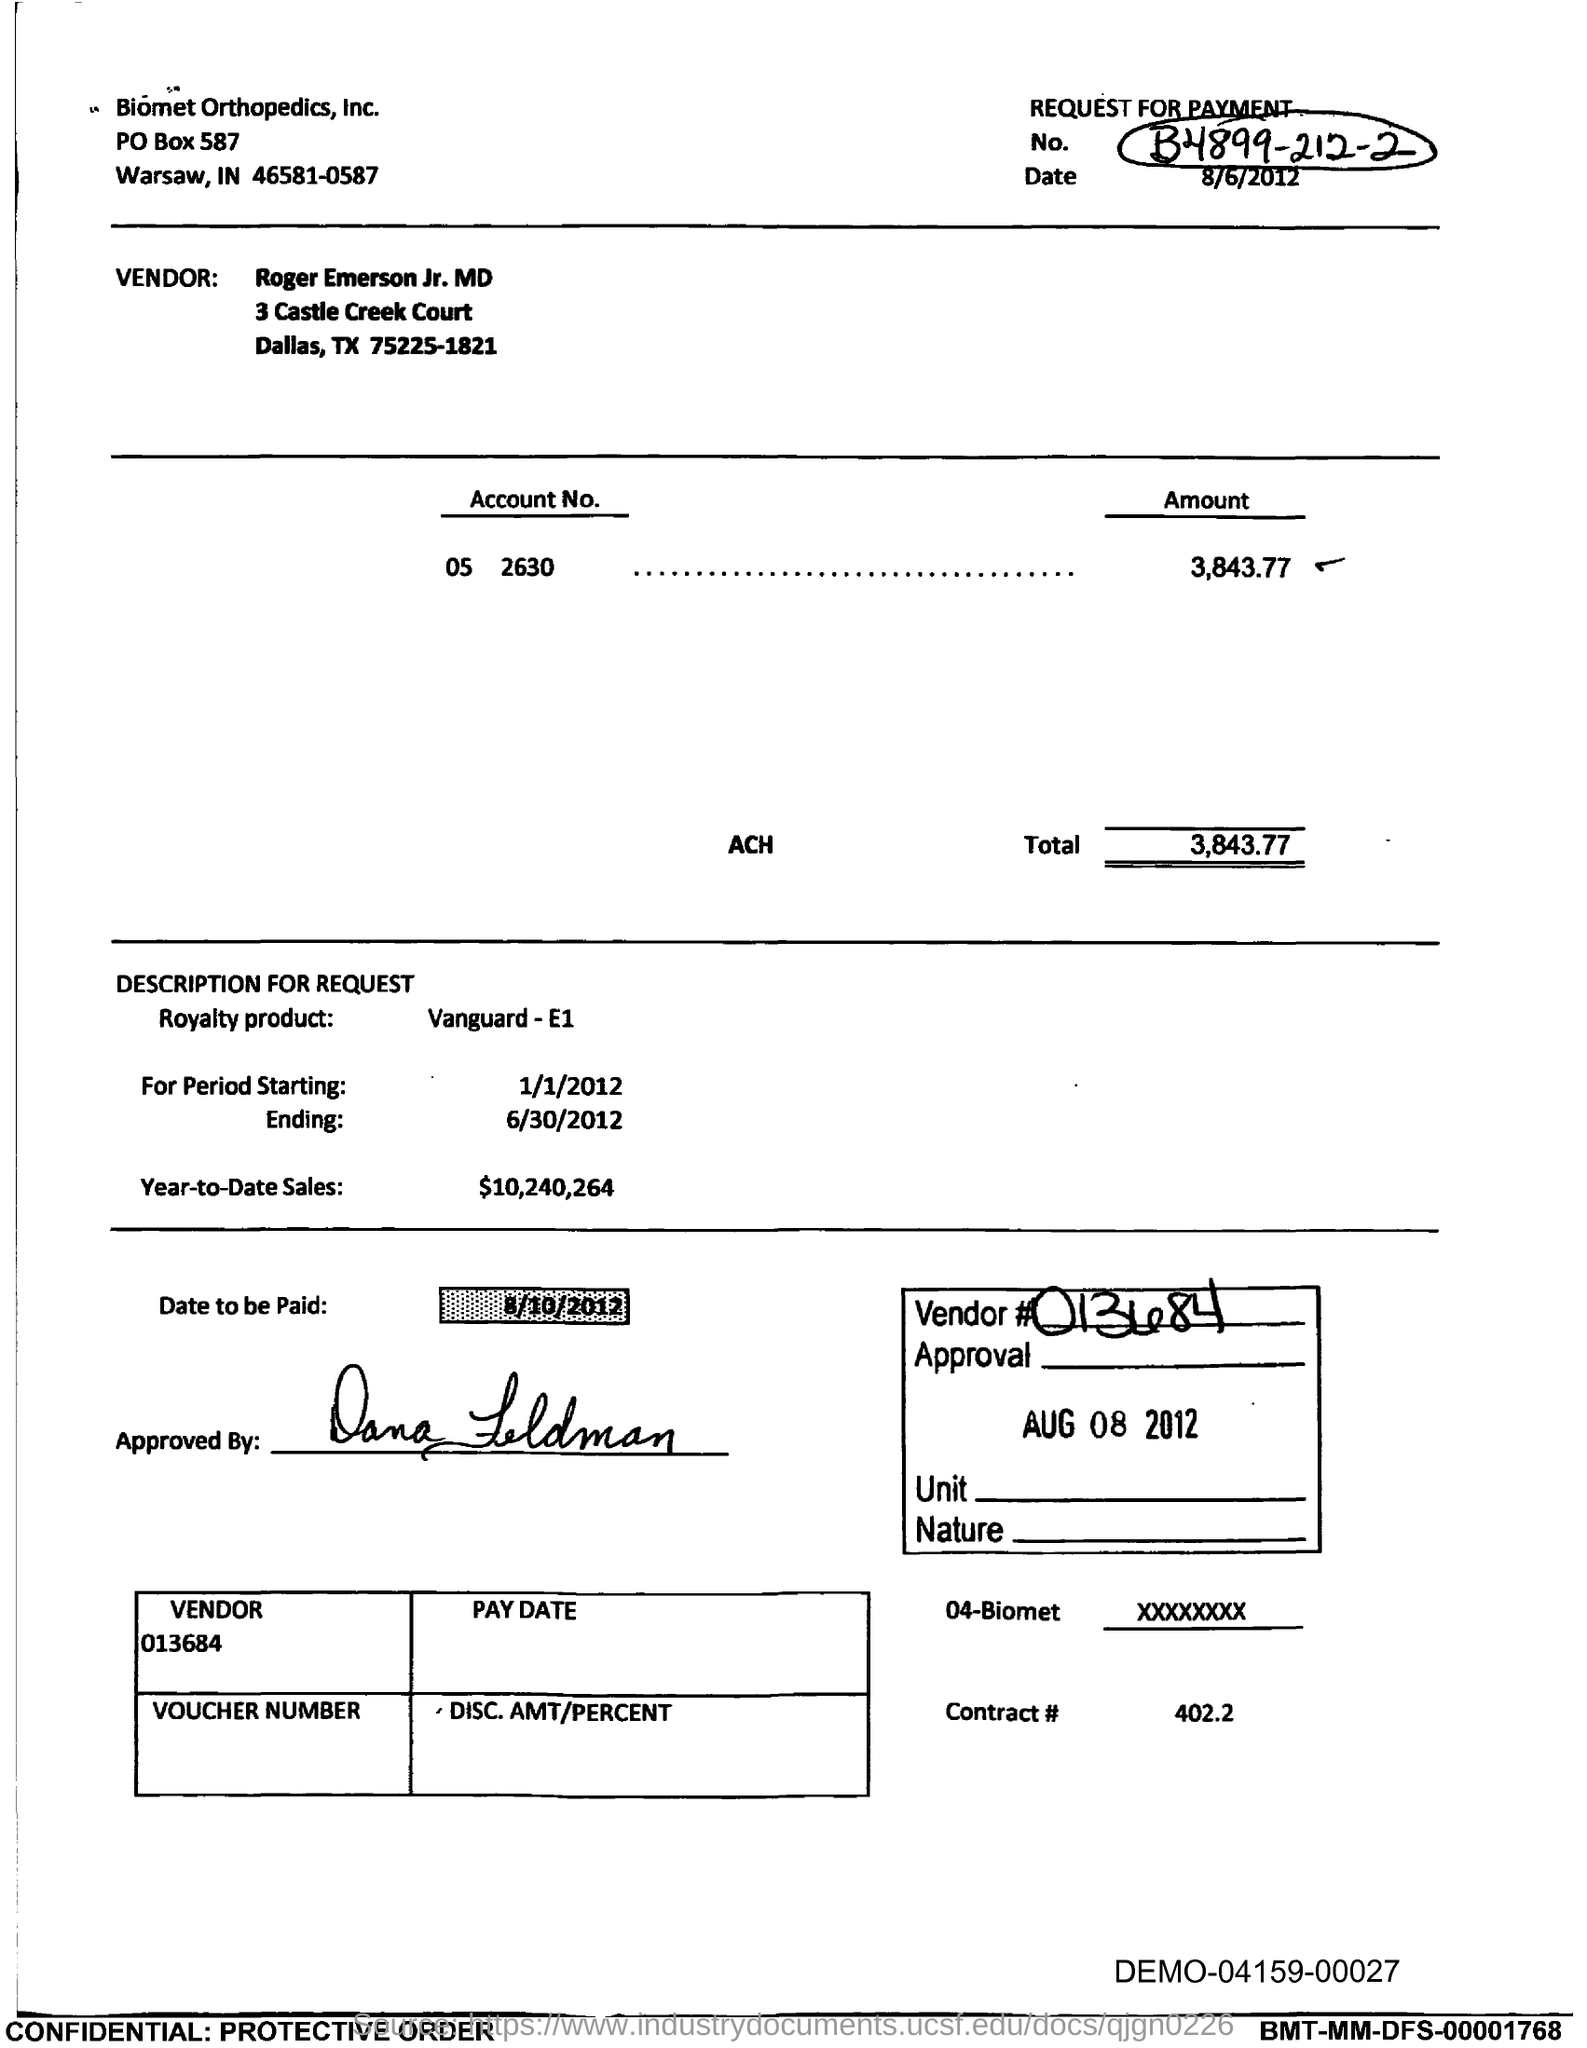What is the name of the vendor?
Give a very brief answer. Roger Emerson Jr. MD. What is the value given for vendor?
Your response must be concise. 013684. What is the date to be paid in this document ?
Provide a succinct answer. 8/10/2012. What is the amount for account no 05 2630
Provide a succinct answer. 3,843.77. What is the total amount given in this document?
Give a very brief answer. 3,843.77. What is the Period Starting date in this document?
Keep it short and to the point. 1/1/2012. What is the ending date given in this document ?
Provide a succinct answer. 6/30/2012. What is the value for Year-to-Date Sales?
Your answer should be very brief. 10,240,264. What is the value given against contract in this document?
Your response must be concise. 402.2. What is the date of this document?
Offer a very short reply. 8/6/2012. 